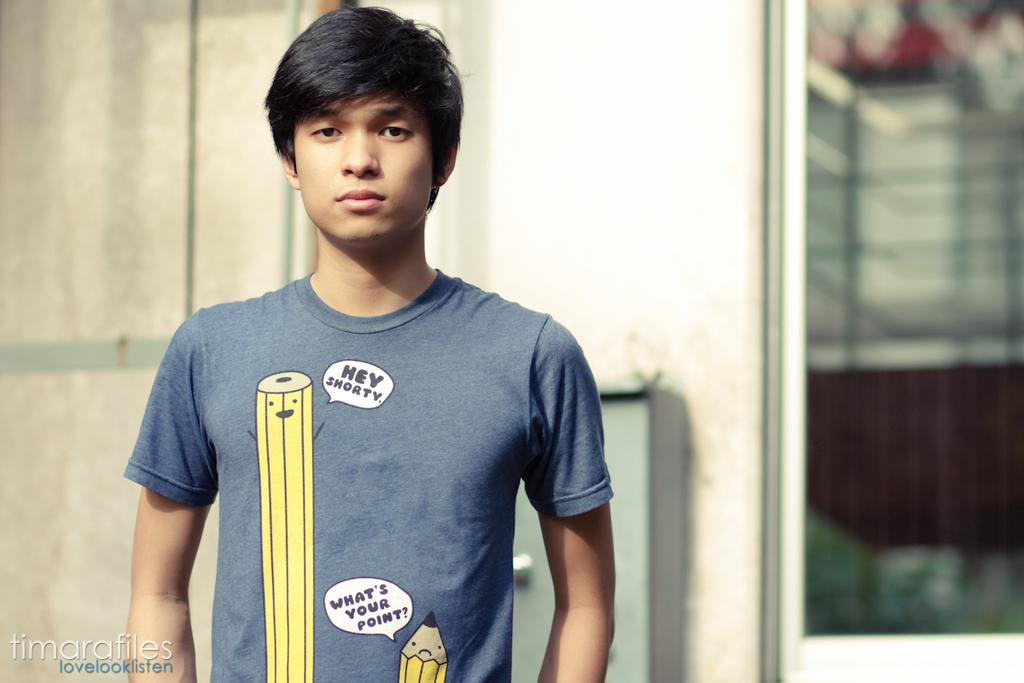<image>
Share a concise interpretation of the image provided. A boy wears a shirt with pencils that are saying Hey Shorty and What's Your Point. 